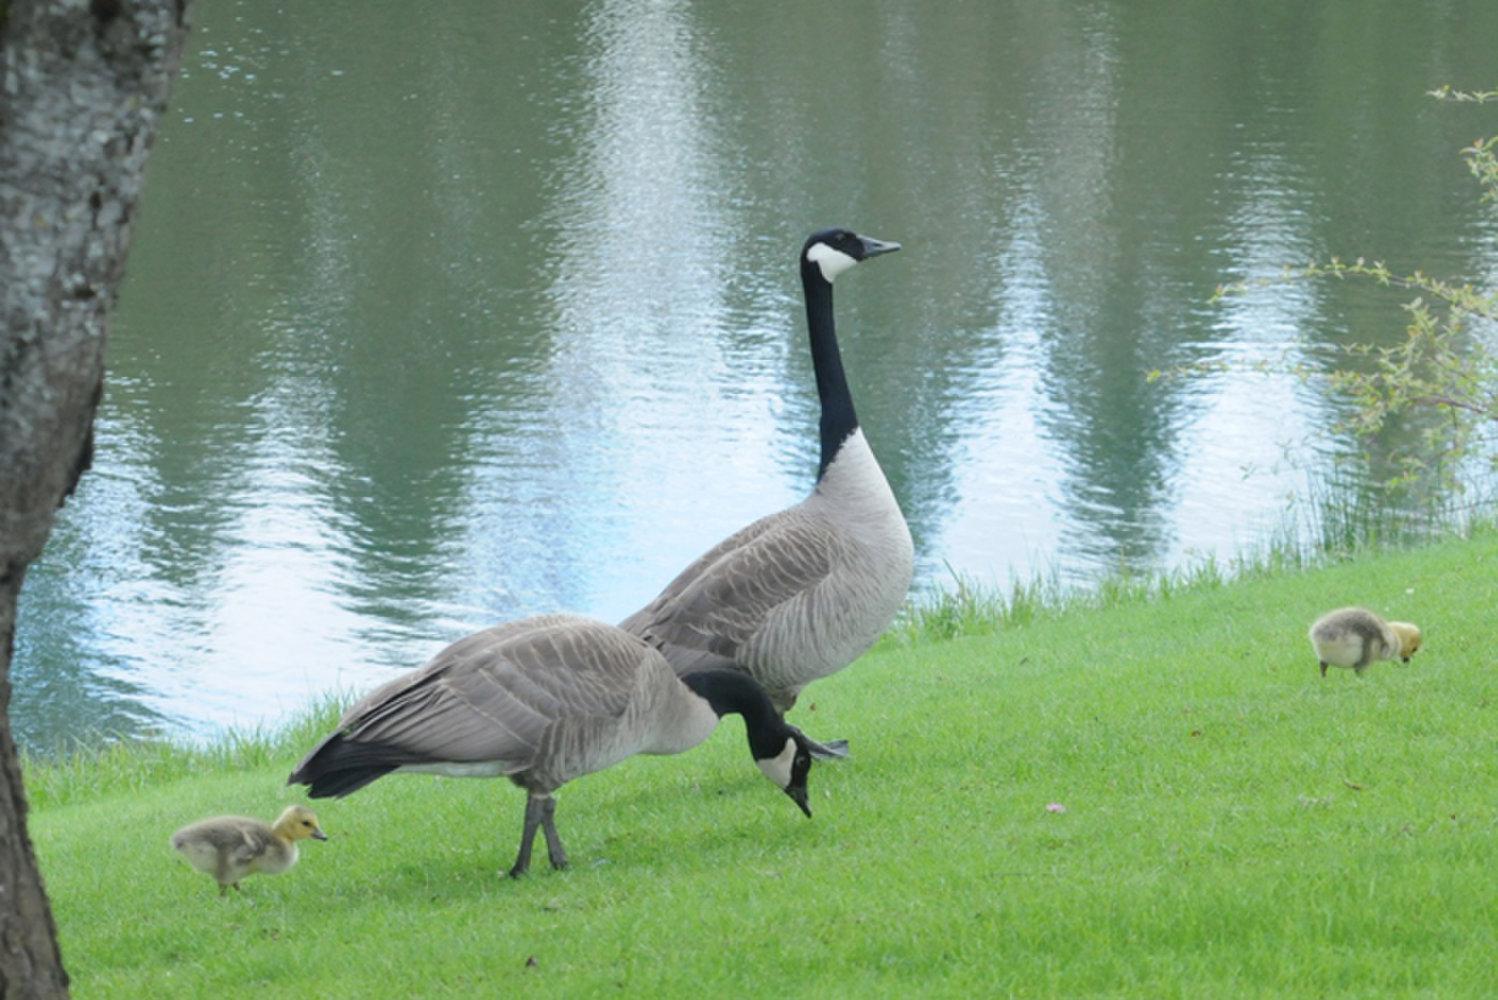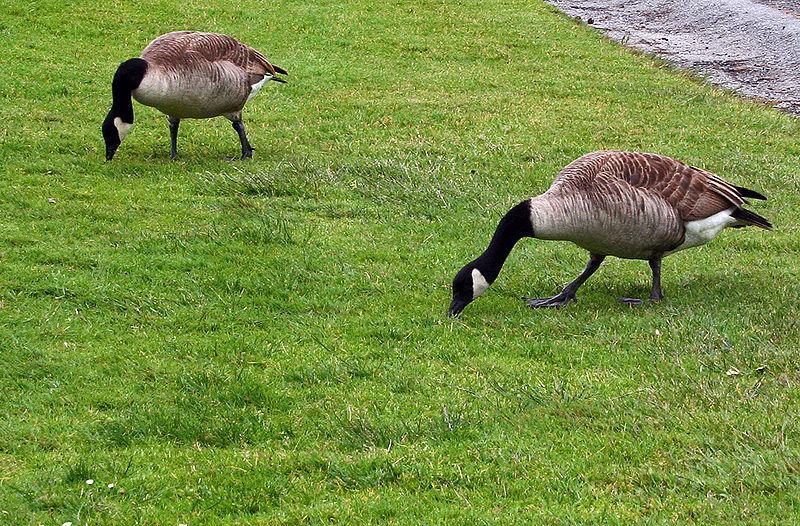The first image is the image on the left, the second image is the image on the right. Given the left and right images, does the statement "There are at least two baby geese." hold true? Answer yes or no. Yes. The first image is the image on the left, the second image is the image on the right. For the images shown, is this caption "There are a handful of goslings (baby geese) in the left image." true? Answer yes or no. Yes. 